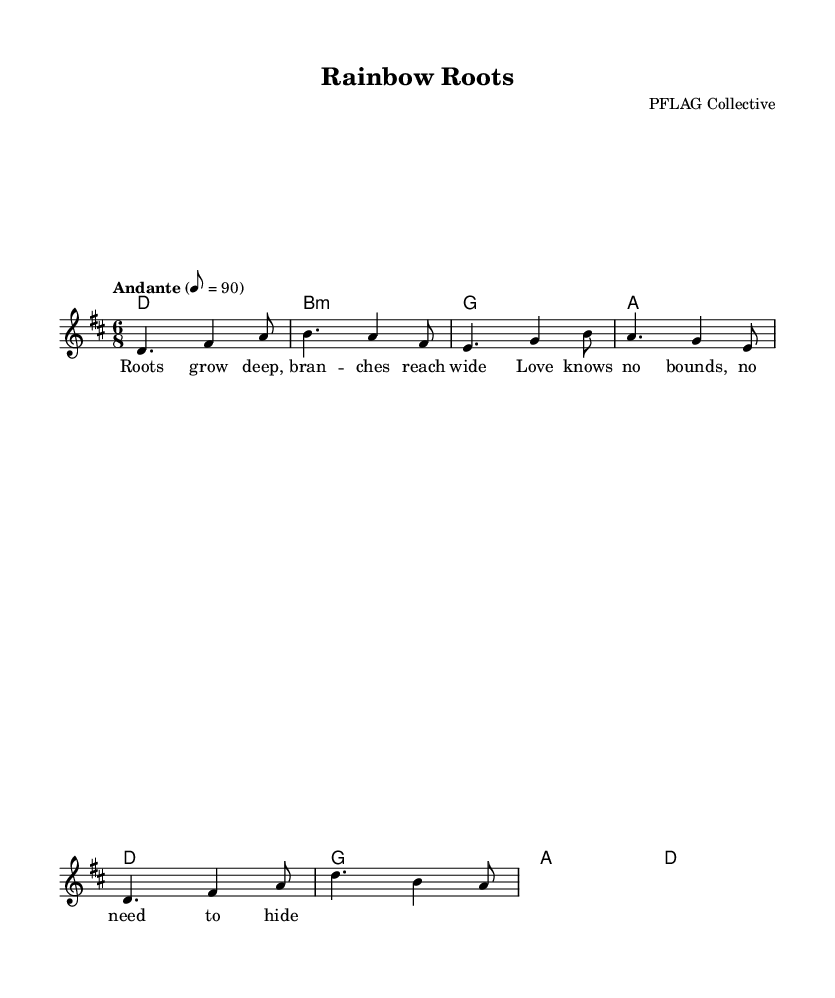What is the key signature of this music? The key signature is D major, which has two sharps (F# and C#). It can be identified by looking at the key signature placed at the beginning of the staff.
Answer: D major What is the time signature of this music? The time signature is 6/8, which indicates that there are six beats in a measure and the eighth note gets the beat. This information is specified at the beginning of the score.
Answer: 6/8 What is the tempo marking of the piece? The tempo marking is Andante, which means at a moderately slow pace. It is indicated in the score above the melody, giving performers guidance on the speed of the piece.
Answer: Andante How many measures are in the melody? The melody contains eight measures in total, which can be counted by observing the bar lines that separate the musical phrases throughout the score.
Answer: Eight What chord follows the D major chord? The chord that follows the D major chord is B minor, as indicated in the chord progression listed beneath the staff. The harmonies are explicitly provided to guide accompaniment.
Answer: B minor What thematic message does the lyrics impart? The lyrics express a theme of love and acceptance across diverse family structures, as indicated in the lines that convey the sentiment of love knowing no bounds. This thematic essence is a hallmark of experimental folk fusion aiming to celebrate chosen families.
Answer: Love knows no bounds What is the structure of the composition in terms of melodic line and harmony? The structure consists of a melody that progresses through a sequence of notes supported by a harmonic framework of chord changes. The combination of a clear melody with complementary harmonies is typical of experimental folk fusion, enhancing the overall emotional impact of the song.
Answer: Melody with chords 